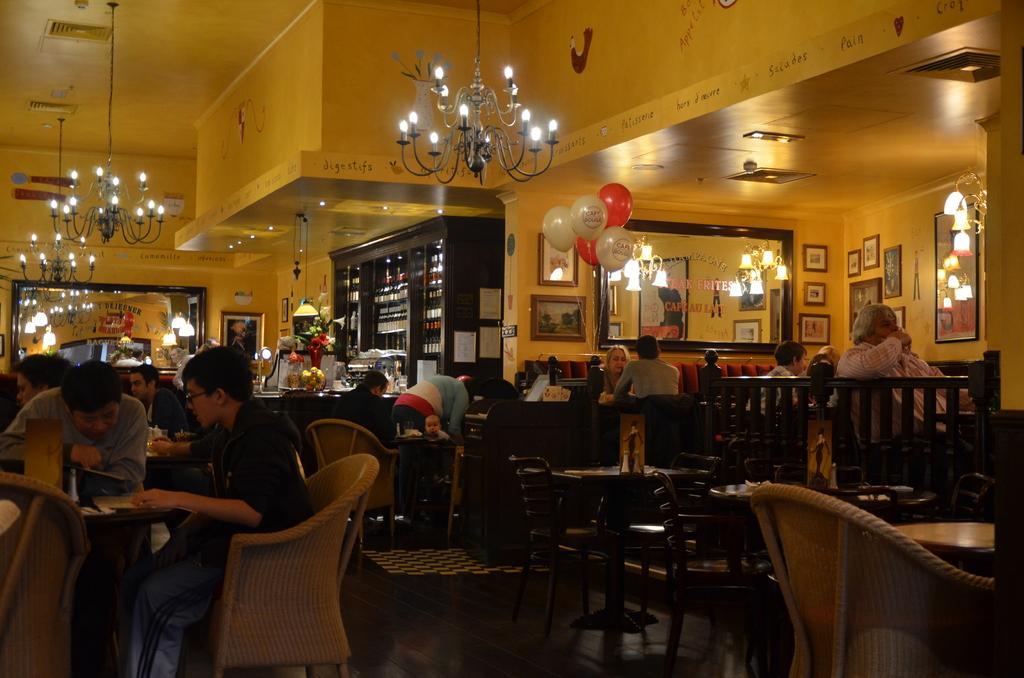Can you describe this image briefly? The picture is taken in a restaurant. In the foreground of the picture there are tables, chairs, people. In the center of the picture there are balloons, mirrors, frames, bookshelf and other objects. At the top there are chandeliers and wall. 